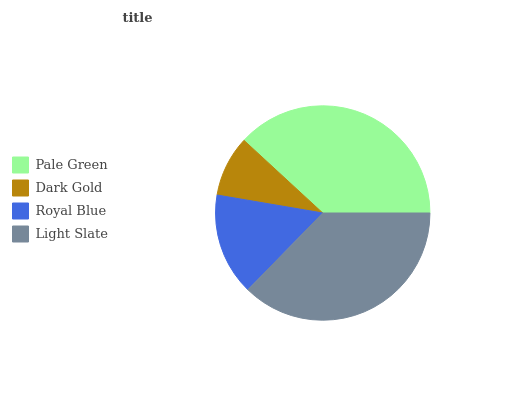Is Dark Gold the minimum?
Answer yes or no. Yes. Is Pale Green the maximum?
Answer yes or no. Yes. Is Royal Blue the minimum?
Answer yes or no. No. Is Royal Blue the maximum?
Answer yes or no. No. Is Royal Blue greater than Dark Gold?
Answer yes or no. Yes. Is Dark Gold less than Royal Blue?
Answer yes or no. Yes. Is Dark Gold greater than Royal Blue?
Answer yes or no. No. Is Royal Blue less than Dark Gold?
Answer yes or no. No. Is Light Slate the high median?
Answer yes or no. Yes. Is Royal Blue the low median?
Answer yes or no. Yes. Is Royal Blue the high median?
Answer yes or no. No. Is Dark Gold the low median?
Answer yes or no. No. 